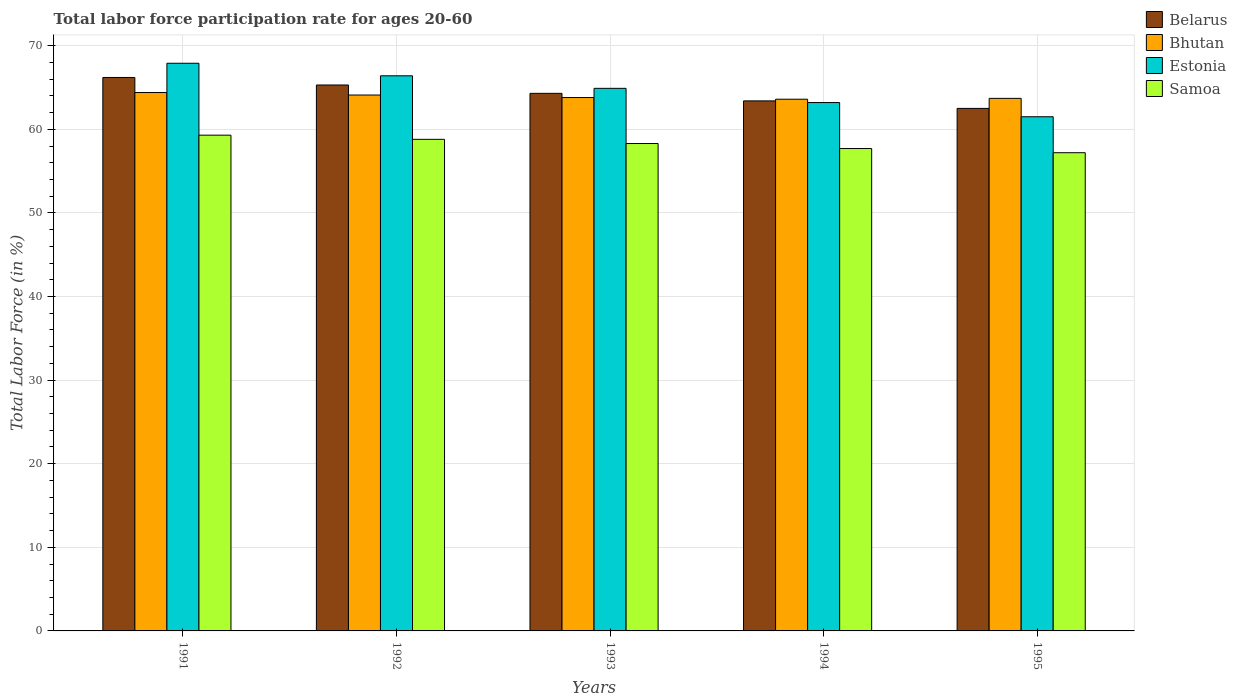How many different coloured bars are there?
Keep it short and to the point. 4. How many groups of bars are there?
Keep it short and to the point. 5. Are the number of bars per tick equal to the number of legend labels?
Ensure brevity in your answer.  Yes. Are the number of bars on each tick of the X-axis equal?
Offer a terse response. Yes. How many bars are there on the 3rd tick from the left?
Your answer should be very brief. 4. How many bars are there on the 5th tick from the right?
Provide a short and direct response. 4. What is the label of the 4th group of bars from the left?
Offer a terse response. 1994. In how many cases, is the number of bars for a given year not equal to the number of legend labels?
Provide a short and direct response. 0. What is the labor force participation rate in Estonia in 1994?
Provide a succinct answer. 63.2. Across all years, what is the maximum labor force participation rate in Belarus?
Make the answer very short. 66.2. Across all years, what is the minimum labor force participation rate in Estonia?
Make the answer very short. 61.5. In which year was the labor force participation rate in Estonia minimum?
Your response must be concise. 1995. What is the total labor force participation rate in Samoa in the graph?
Your response must be concise. 291.3. What is the difference between the labor force participation rate in Bhutan in 1992 and that in 1995?
Offer a very short reply. 0.4. What is the difference between the labor force participation rate in Bhutan in 1993 and the labor force participation rate in Samoa in 1991?
Ensure brevity in your answer.  4.5. What is the average labor force participation rate in Belarus per year?
Provide a short and direct response. 64.34. In the year 1994, what is the difference between the labor force participation rate in Bhutan and labor force participation rate in Estonia?
Your answer should be very brief. 0.4. In how many years, is the labor force participation rate in Samoa greater than 58 %?
Make the answer very short. 3. What is the ratio of the labor force participation rate in Bhutan in 1993 to that in 1995?
Make the answer very short. 1. Is the difference between the labor force participation rate in Bhutan in 1991 and 1995 greater than the difference between the labor force participation rate in Estonia in 1991 and 1995?
Provide a succinct answer. No. What is the difference between the highest and the lowest labor force participation rate in Estonia?
Your response must be concise. 6.4. In how many years, is the labor force participation rate in Belarus greater than the average labor force participation rate in Belarus taken over all years?
Provide a succinct answer. 2. What does the 1st bar from the left in 1993 represents?
Ensure brevity in your answer.  Belarus. What does the 3rd bar from the right in 1991 represents?
Keep it short and to the point. Bhutan. Is it the case that in every year, the sum of the labor force participation rate in Bhutan and labor force participation rate in Samoa is greater than the labor force participation rate in Estonia?
Make the answer very short. Yes. Are all the bars in the graph horizontal?
Ensure brevity in your answer.  No. What is the difference between two consecutive major ticks on the Y-axis?
Offer a terse response. 10. Does the graph contain grids?
Keep it short and to the point. Yes. Where does the legend appear in the graph?
Ensure brevity in your answer.  Top right. How many legend labels are there?
Provide a short and direct response. 4. How are the legend labels stacked?
Keep it short and to the point. Vertical. What is the title of the graph?
Keep it short and to the point. Total labor force participation rate for ages 20-60. Does "New Caledonia" appear as one of the legend labels in the graph?
Your response must be concise. No. What is the Total Labor Force (in %) of Belarus in 1991?
Your answer should be compact. 66.2. What is the Total Labor Force (in %) in Bhutan in 1991?
Your response must be concise. 64.4. What is the Total Labor Force (in %) of Estonia in 1991?
Your answer should be compact. 67.9. What is the Total Labor Force (in %) of Samoa in 1991?
Offer a terse response. 59.3. What is the Total Labor Force (in %) of Belarus in 1992?
Your answer should be compact. 65.3. What is the Total Labor Force (in %) of Bhutan in 1992?
Provide a short and direct response. 64.1. What is the Total Labor Force (in %) of Estonia in 1992?
Make the answer very short. 66.4. What is the Total Labor Force (in %) in Samoa in 1992?
Provide a short and direct response. 58.8. What is the Total Labor Force (in %) in Belarus in 1993?
Provide a short and direct response. 64.3. What is the Total Labor Force (in %) in Bhutan in 1993?
Offer a very short reply. 63.8. What is the Total Labor Force (in %) of Estonia in 1993?
Give a very brief answer. 64.9. What is the Total Labor Force (in %) of Samoa in 1993?
Offer a terse response. 58.3. What is the Total Labor Force (in %) in Belarus in 1994?
Make the answer very short. 63.4. What is the Total Labor Force (in %) in Bhutan in 1994?
Give a very brief answer. 63.6. What is the Total Labor Force (in %) in Estonia in 1994?
Give a very brief answer. 63.2. What is the Total Labor Force (in %) in Samoa in 1994?
Your answer should be compact. 57.7. What is the Total Labor Force (in %) of Belarus in 1995?
Your response must be concise. 62.5. What is the Total Labor Force (in %) of Bhutan in 1995?
Your response must be concise. 63.7. What is the Total Labor Force (in %) of Estonia in 1995?
Ensure brevity in your answer.  61.5. What is the Total Labor Force (in %) in Samoa in 1995?
Your answer should be very brief. 57.2. Across all years, what is the maximum Total Labor Force (in %) in Belarus?
Ensure brevity in your answer.  66.2. Across all years, what is the maximum Total Labor Force (in %) of Bhutan?
Give a very brief answer. 64.4. Across all years, what is the maximum Total Labor Force (in %) in Estonia?
Provide a succinct answer. 67.9. Across all years, what is the maximum Total Labor Force (in %) in Samoa?
Provide a succinct answer. 59.3. Across all years, what is the minimum Total Labor Force (in %) in Belarus?
Offer a terse response. 62.5. Across all years, what is the minimum Total Labor Force (in %) of Bhutan?
Your response must be concise. 63.6. Across all years, what is the minimum Total Labor Force (in %) of Estonia?
Give a very brief answer. 61.5. Across all years, what is the minimum Total Labor Force (in %) in Samoa?
Your answer should be compact. 57.2. What is the total Total Labor Force (in %) of Belarus in the graph?
Offer a terse response. 321.7. What is the total Total Labor Force (in %) of Bhutan in the graph?
Your response must be concise. 319.6. What is the total Total Labor Force (in %) in Estonia in the graph?
Give a very brief answer. 323.9. What is the total Total Labor Force (in %) in Samoa in the graph?
Your answer should be compact. 291.3. What is the difference between the Total Labor Force (in %) in Bhutan in 1991 and that in 1992?
Your response must be concise. 0.3. What is the difference between the Total Labor Force (in %) in Estonia in 1991 and that in 1992?
Give a very brief answer. 1.5. What is the difference between the Total Labor Force (in %) in Samoa in 1991 and that in 1992?
Keep it short and to the point. 0.5. What is the difference between the Total Labor Force (in %) in Bhutan in 1991 and that in 1993?
Make the answer very short. 0.6. What is the difference between the Total Labor Force (in %) of Belarus in 1991 and that in 1994?
Your answer should be compact. 2.8. What is the difference between the Total Labor Force (in %) in Belarus in 1991 and that in 1995?
Keep it short and to the point. 3.7. What is the difference between the Total Labor Force (in %) of Samoa in 1991 and that in 1995?
Offer a very short reply. 2.1. What is the difference between the Total Labor Force (in %) in Estonia in 1992 and that in 1993?
Ensure brevity in your answer.  1.5. What is the difference between the Total Labor Force (in %) of Samoa in 1992 and that in 1993?
Your answer should be very brief. 0.5. What is the difference between the Total Labor Force (in %) in Estonia in 1992 and that in 1994?
Your response must be concise. 3.2. What is the difference between the Total Labor Force (in %) of Belarus in 1992 and that in 1995?
Give a very brief answer. 2.8. What is the difference between the Total Labor Force (in %) of Bhutan in 1992 and that in 1995?
Ensure brevity in your answer.  0.4. What is the difference between the Total Labor Force (in %) in Samoa in 1992 and that in 1995?
Make the answer very short. 1.6. What is the difference between the Total Labor Force (in %) in Belarus in 1993 and that in 1994?
Make the answer very short. 0.9. What is the difference between the Total Labor Force (in %) of Samoa in 1993 and that in 1994?
Ensure brevity in your answer.  0.6. What is the difference between the Total Labor Force (in %) of Bhutan in 1993 and that in 1995?
Make the answer very short. 0.1. What is the difference between the Total Labor Force (in %) of Estonia in 1993 and that in 1995?
Offer a very short reply. 3.4. What is the difference between the Total Labor Force (in %) in Samoa in 1993 and that in 1995?
Make the answer very short. 1.1. What is the difference between the Total Labor Force (in %) of Belarus in 1994 and that in 1995?
Provide a succinct answer. 0.9. What is the difference between the Total Labor Force (in %) of Belarus in 1991 and the Total Labor Force (in %) of Bhutan in 1992?
Your answer should be compact. 2.1. What is the difference between the Total Labor Force (in %) of Belarus in 1991 and the Total Labor Force (in %) of Samoa in 1992?
Your answer should be compact. 7.4. What is the difference between the Total Labor Force (in %) of Bhutan in 1991 and the Total Labor Force (in %) of Samoa in 1992?
Offer a terse response. 5.6. What is the difference between the Total Labor Force (in %) in Estonia in 1991 and the Total Labor Force (in %) in Samoa in 1992?
Offer a very short reply. 9.1. What is the difference between the Total Labor Force (in %) in Belarus in 1991 and the Total Labor Force (in %) in Estonia in 1993?
Your response must be concise. 1.3. What is the difference between the Total Labor Force (in %) of Belarus in 1991 and the Total Labor Force (in %) of Samoa in 1993?
Your answer should be compact. 7.9. What is the difference between the Total Labor Force (in %) of Belarus in 1991 and the Total Labor Force (in %) of Bhutan in 1994?
Provide a short and direct response. 2.6. What is the difference between the Total Labor Force (in %) in Belarus in 1991 and the Total Labor Force (in %) in Samoa in 1994?
Give a very brief answer. 8.5. What is the difference between the Total Labor Force (in %) in Bhutan in 1991 and the Total Labor Force (in %) in Estonia in 1994?
Keep it short and to the point. 1.2. What is the difference between the Total Labor Force (in %) of Bhutan in 1991 and the Total Labor Force (in %) of Samoa in 1994?
Keep it short and to the point. 6.7. What is the difference between the Total Labor Force (in %) in Belarus in 1991 and the Total Labor Force (in %) in Estonia in 1995?
Offer a terse response. 4.7. What is the difference between the Total Labor Force (in %) in Estonia in 1991 and the Total Labor Force (in %) in Samoa in 1995?
Make the answer very short. 10.7. What is the difference between the Total Labor Force (in %) in Belarus in 1992 and the Total Labor Force (in %) in Estonia in 1993?
Give a very brief answer. 0.4. What is the difference between the Total Labor Force (in %) in Belarus in 1992 and the Total Labor Force (in %) in Samoa in 1993?
Provide a succinct answer. 7. What is the difference between the Total Labor Force (in %) in Bhutan in 1992 and the Total Labor Force (in %) in Samoa in 1993?
Provide a short and direct response. 5.8. What is the difference between the Total Labor Force (in %) of Estonia in 1992 and the Total Labor Force (in %) of Samoa in 1993?
Your answer should be very brief. 8.1. What is the difference between the Total Labor Force (in %) in Belarus in 1992 and the Total Labor Force (in %) in Bhutan in 1994?
Offer a terse response. 1.7. What is the difference between the Total Labor Force (in %) in Belarus in 1992 and the Total Labor Force (in %) in Estonia in 1994?
Give a very brief answer. 2.1. What is the difference between the Total Labor Force (in %) of Belarus in 1992 and the Total Labor Force (in %) of Samoa in 1995?
Provide a short and direct response. 8.1. What is the difference between the Total Labor Force (in %) of Bhutan in 1992 and the Total Labor Force (in %) of Estonia in 1995?
Offer a terse response. 2.6. What is the difference between the Total Labor Force (in %) of Belarus in 1993 and the Total Labor Force (in %) of Bhutan in 1994?
Your response must be concise. 0.7. What is the difference between the Total Labor Force (in %) in Bhutan in 1993 and the Total Labor Force (in %) in Samoa in 1994?
Your answer should be very brief. 6.1. What is the difference between the Total Labor Force (in %) of Estonia in 1993 and the Total Labor Force (in %) of Samoa in 1994?
Ensure brevity in your answer.  7.2. What is the difference between the Total Labor Force (in %) of Belarus in 1993 and the Total Labor Force (in %) of Bhutan in 1995?
Offer a terse response. 0.6. What is the difference between the Total Labor Force (in %) of Belarus in 1994 and the Total Labor Force (in %) of Estonia in 1995?
Offer a terse response. 1.9. What is the difference between the Total Labor Force (in %) of Estonia in 1994 and the Total Labor Force (in %) of Samoa in 1995?
Give a very brief answer. 6. What is the average Total Labor Force (in %) of Belarus per year?
Your response must be concise. 64.34. What is the average Total Labor Force (in %) in Bhutan per year?
Provide a short and direct response. 63.92. What is the average Total Labor Force (in %) in Estonia per year?
Make the answer very short. 64.78. What is the average Total Labor Force (in %) in Samoa per year?
Your response must be concise. 58.26. In the year 1991, what is the difference between the Total Labor Force (in %) in Belarus and Total Labor Force (in %) in Estonia?
Provide a short and direct response. -1.7. In the year 1991, what is the difference between the Total Labor Force (in %) of Belarus and Total Labor Force (in %) of Samoa?
Make the answer very short. 6.9. In the year 1991, what is the difference between the Total Labor Force (in %) in Bhutan and Total Labor Force (in %) in Samoa?
Make the answer very short. 5.1. In the year 1991, what is the difference between the Total Labor Force (in %) of Estonia and Total Labor Force (in %) of Samoa?
Provide a succinct answer. 8.6. In the year 1992, what is the difference between the Total Labor Force (in %) of Belarus and Total Labor Force (in %) of Bhutan?
Make the answer very short. 1.2. In the year 1992, what is the difference between the Total Labor Force (in %) in Belarus and Total Labor Force (in %) in Estonia?
Offer a very short reply. -1.1. In the year 1992, what is the difference between the Total Labor Force (in %) of Bhutan and Total Labor Force (in %) of Estonia?
Your answer should be compact. -2.3. In the year 1992, what is the difference between the Total Labor Force (in %) in Bhutan and Total Labor Force (in %) in Samoa?
Ensure brevity in your answer.  5.3. In the year 1992, what is the difference between the Total Labor Force (in %) of Estonia and Total Labor Force (in %) of Samoa?
Your answer should be very brief. 7.6. In the year 1993, what is the difference between the Total Labor Force (in %) of Bhutan and Total Labor Force (in %) of Samoa?
Keep it short and to the point. 5.5. In the year 1994, what is the difference between the Total Labor Force (in %) of Belarus and Total Labor Force (in %) of Samoa?
Provide a short and direct response. 5.7. In the year 1994, what is the difference between the Total Labor Force (in %) in Bhutan and Total Labor Force (in %) in Estonia?
Give a very brief answer. 0.4. In the year 1994, what is the difference between the Total Labor Force (in %) in Bhutan and Total Labor Force (in %) in Samoa?
Provide a succinct answer. 5.9. In the year 1994, what is the difference between the Total Labor Force (in %) in Estonia and Total Labor Force (in %) in Samoa?
Offer a terse response. 5.5. In the year 1995, what is the difference between the Total Labor Force (in %) in Belarus and Total Labor Force (in %) in Bhutan?
Provide a succinct answer. -1.2. In the year 1995, what is the difference between the Total Labor Force (in %) of Belarus and Total Labor Force (in %) of Samoa?
Your answer should be compact. 5.3. What is the ratio of the Total Labor Force (in %) in Belarus in 1991 to that in 1992?
Make the answer very short. 1.01. What is the ratio of the Total Labor Force (in %) of Bhutan in 1991 to that in 1992?
Provide a succinct answer. 1. What is the ratio of the Total Labor Force (in %) in Estonia in 1991 to that in 1992?
Offer a terse response. 1.02. What is the ratio of the Total Labor Force (in %) of Samoa in 1991 to that in 1992?
Ensure brevity in your answer.  1.01. What is the ratio of the Total Labor Force (in %) in Belarus in 1991 to that in 1993?
Provide a short and direct response. 1.03. What is the ratio of the Total Labor Force (in %) in Bhutan in 1991 to that in 1993?
Your answer should be compact. 1.01. What is the ratio of the Total Labor Force (in %) of Estonia in 1991 to that in 1993?
Your response must be concise. 1.05. What is the ratio of the Total Labor Force (in %) in Samoa in 1991 to that in 1993?
Provide a succinct answer. 1.02. What is the ratio of the Total Labor Force (in %) of Belarus in 1991 to that in 1994?
Provide a short and direct response. 1.04. What is the ratio of the Total Labor Force (in %) in Bhutan in 1991 to that in 1994?
Offer a very short reply. 1.01. What is the ratio of the Total Labor Force (in %) in Estonia in 1991 to that in 1994?
Offer a very short reply. 1.07. What is the ratio of the Total Labor Force (in %) of Samoa in 1991 to that in 1994?
Keep it short and to the point. 1.03. What is the ratio of the Total Labor Force (in %) of Belarus in 1991 to that in 1995?
Your answer should be compact. 1.06. What is the ratio of the Total Labor Force (in %) in Estonia in 1991 to that in 1995?
Keep it short and to the point. 1.1. What is the ratio of the Total Labor Force (in %) of Samoa in 1991 to that in 1995?
Offer a terse response. 1.04. What is the ratio of the Total Labor Force (in %) in Belarus in 1992 to that in 1993?
Offer a very short reply. 1.02. What is the ratio of the Total Labor Force (in %) of Estonia in 1992 to that in 1993?
Make the answer very short. 1.02. What is the ratio of the Total Labor Force (in %) of Samoa in 1992 to that in 1993?
Offer a terse response. 1.01. What is the ratio of the Total Labor Force (in %) in Bhutan in 1992 to that in 1994?
Make the answer very short. 1.01. What is the ratio of the Total Labor Force (in %) in Estonia in 1992 to that in 1994?
Offer a terse response. 1.05. What is the ratio of the Total Labor Force (in %) of Samoa in 1992 to that in 1994?
Your response must be concise. 1.02. What is the ratio of the Total Labor Force (in %) of Belarus in 1992 to that in 1995?
Ensure brevity in your answer.  1.04. What is the ratio of the Total Labor Force (in %) in Bhutan in 1992 to that in 1995?
Provide a short and direct response. 1.01. What is the ratio of the Total Labor Force (in %) of Estonia in 1992 to that in 1995?
Ensure brevity in your answer.  1.08. What is the ratio of the Total Labor Force (in %) in Samoa in 1992 to that in 1995?
Offer a very short reply. 1.03. What is the ratio of the Total Labor Force (in %) in Belarus in 1993 to that in 1994?
Provide a short and direct response. 1.01. What is the ratio of the Total Labor Force (in %) of Estonia in 1993 to that in 1994?
Ensure brevity in your answer.  1.03. What is the ratio of the Total Labor Force (in %) of Samoa in 1993 to that in 1994?
Ensure brevity in your answer.  1.01. What is the ratio of the Total Labor Force (in %) in Belarus in 1993 to that in 1995?
Offer a very short reply. 1.03. What is the ratio of the Total Labor Force (in %) in Estonia in 1993 to that in 1995?
Your answer should be very brief. 1.06. What is the ratio of the Total Labor Force (in %) in Samoa in 1993 to that in 1995?
Offer a terse response. 1.02. What is the ratio of the Total Labor Force (in %) of Belarus in 1994 to that in 1995?
Make the answer very short. 1.01. What is the ratio of the Total Labor Force (in %) in Estonia in 1994 to that in 1995?
Your answer should be compact. 1.03. What is the ratio of the Total Labor Force (in %) in Samoa in 1994 to that in 1995?
Your answer should be compact. 1.01. What is the difference between the highest and the second highest Total Labor Force (in %) of Bhutan?
Provide a short and direct response. 0.3. What is the difference between the highest and the second highest Total Labor Force (in %) in Estonia?
Make the answer very short. 1.5. What is the difference between the highest and the lowest Total Labor Force (in %) in Bhutan?
Ensure brevity in your answer.  0.8. What is the difference between the highest and the lowest Total Labor Force (in %) in Estonia?
Provide a short and direct response. 6.4. 